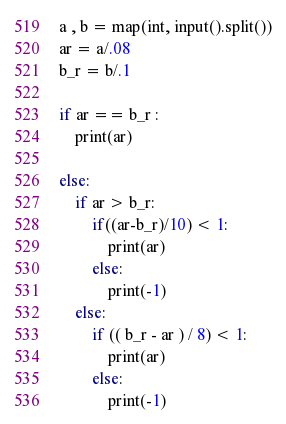<code> <loc_0><loc_0><loc_500><loc_500><_Python_>a , b = map(int, input().split())
ar = a/.08
b_r = b/.1

if ar == b_r :
    print(ar)

else:
    if ar > b_r:
        if((ar-b_r)/10) < 1:
            print(ar)
        else:
            print(-1)
    else:
        if (( b_r - ar ) / 8) < 1:
            print(ar)
        else:
            print(-1)</code> 